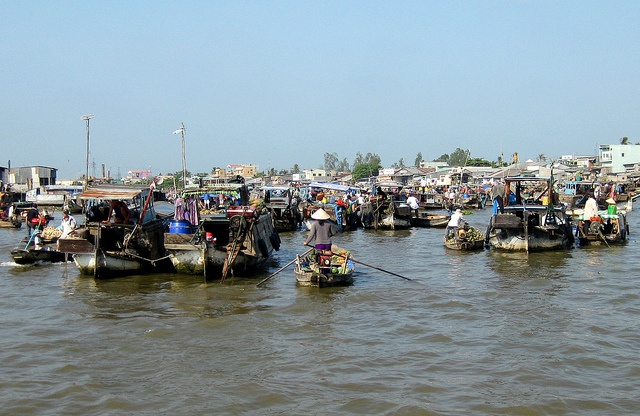Describe the objects in this image and their specific colors. I can see boat in lightblue, black, gray, darkgray, and maroon tones, boat in lightblue, black, gray, darkgray, and darkgreen tones, boat in lightblue, black, gray, darkgray, and ivory tones, boat in lightblue, black, gray, tan, and darkgray tones, and boat in lightblue, black, gray, and darkgray tones in this image. 